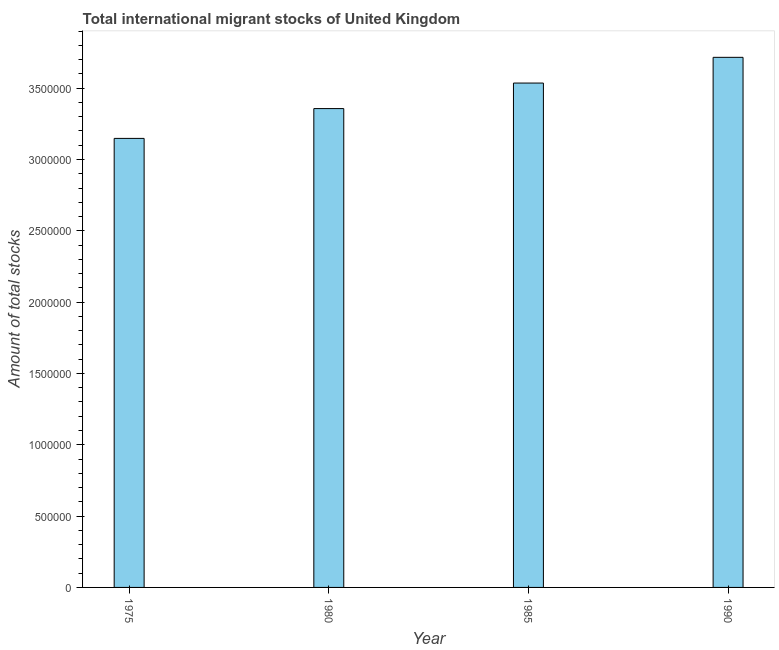Does the graph contain any zero values?
Make the answer very short. No. Does the graph contain grids?
Your answer should be very brief. No. What is the title of the graph?
Ensure brevity in your answer.  Total international migrant stocks of United Kingdom. What is the label or title of the Y-axis?
Make the answer very short. Amount of total stocks. What is the total number of international migrant stock in 1990?
Give a very brief answer. 3.72e+06. Across all years, what is the maximum total number of international migrant stock?
Offer a very short reply. 3.72e+06. Across all years, what is the minimum total number of international migrant stock?
Ensure brevity in your answer.  3.15e+06. In which year was the total number of international migrant stock maximum?
Give a very brief answer. 1990. In which year was the total number of international migrant stock minimum?
Your response must be concise. 1975. What is the sum of the total number of international migrant stock?
Ensure brevity in your answer.  1.38e+07. What is the difference between the total number of international migrant stock in 1975 and 1985?
Your answer should be very brief. -3.88e+05. What is the average total number of international migrant stock per year?
Keep it short and to the point. 3.44e+06. What is the median total number of international migrant stock?
Offer a very short reply. 3.45e+06. What is the ratio of the total number of international migrant stock in 1980 to that in 1990?
Offer a very short reply. 0.9. Is the total number of international migrant stock in 1980 less than that in 1985?
Make the answer very short. Yes. What is the difference between the highest and the second highest total number of international migrant stock?
Provide a short and direct response. 1.80e+05. What is the difference between the highest and the lowest total number of international migrant stock?
Offer a very short reply. 5.68e+05. How many bars are there?
Make the answer very short. 4. Are the values on the major ticks of Y-axis written in scientific E-notation?
Make the answer very short. No. What is the Amount of total stocks of 1975?
Provide a short and direct response. 3.15e+06. What is the Amount of total stocks of 1980?
Provide a succinct answer. 3.36e+06. What is the Amount of total stocks of 1985?
Provide a succinct answer. 3.54e+06. What is the Amount of total stocks of 1990?
Your answer should be compact. 3.72e+06. What is the difference between the Amount of total stocks in 1975 and 1980?
Provide a succinct answer. -2.09e+05. What is the difference between the Amount of total stocks in 1975 and 1985?
Your answer should be very brief. -3.88e+05. What is the difference between the Amount of total stocks in 1975 and 1990?
Offer a terse response. -5.68e+05. What is the difference between the Amount of total stocks in 1980 and 1985?
Offer a terse response. -1.79e+05. What is the difference between the Amount of total stocks in 1980 and 1990?
Your response must be concise. -3.59e+05. What is the difference between the Amount of total stocks in 1985 and 1990?
Your answer should be compact. -1.80e+05. What is the ratio of the Amount of total stocks in 1975 to that in 1980?
Your response must be concise. 0.94. What is the ratio of the Amount of total stocks in 1975 to that in 1985?
Make the answer very short. 0.89. What is the ratio of the Amount of total stocks in 1975 to that in 1990?
Offer a very short reply. 0.85. What is the ratio of the Amount of total stocks in 1980 to that in 1985?
Give a very brief answer. 0.95. What is the ratio of the Amount of total stocks in 1980 to that in 1990?
Give a very brief answer. 0.9. What is the ratio of the Amount of total stocks in 1985 to that in 1990?
Make the answer very short. 0.95. 